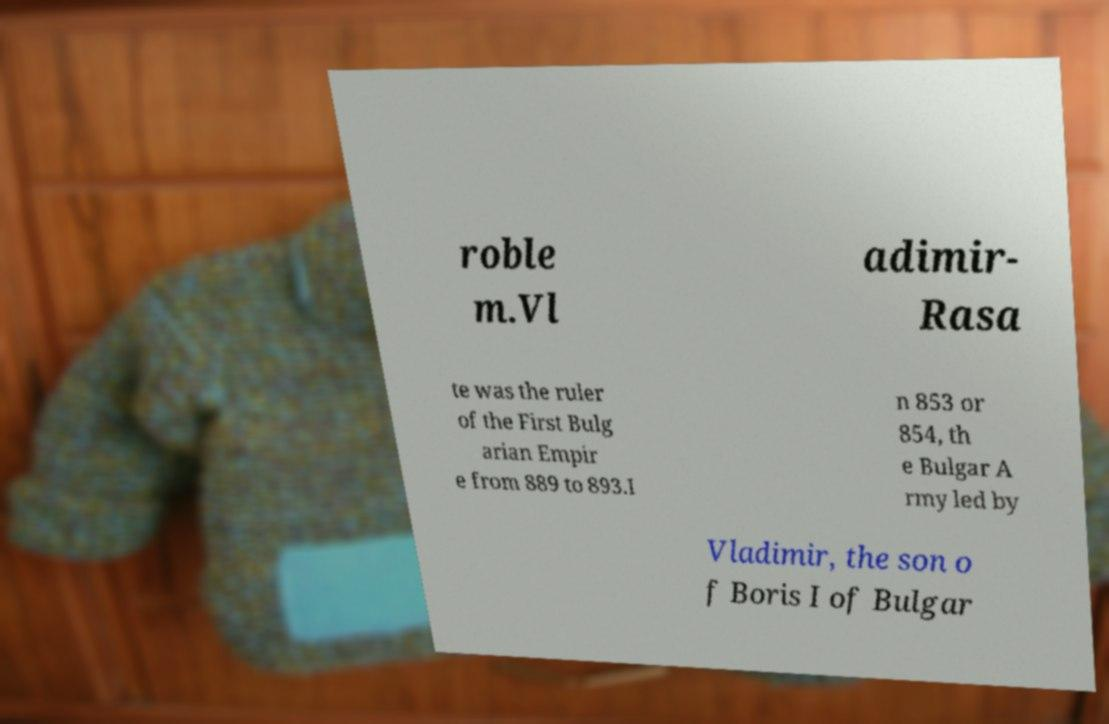For documentation purposes, I need the text within this image transcribed. Could you provide that? roble m.Vl adimir- Rasa te was the ruler of the First Bulg arian Empir e from 889 to 893.I n 853 or 854, th e Bulgar A rmy led by Vladimir, the son o f Boris I of Bulgar 